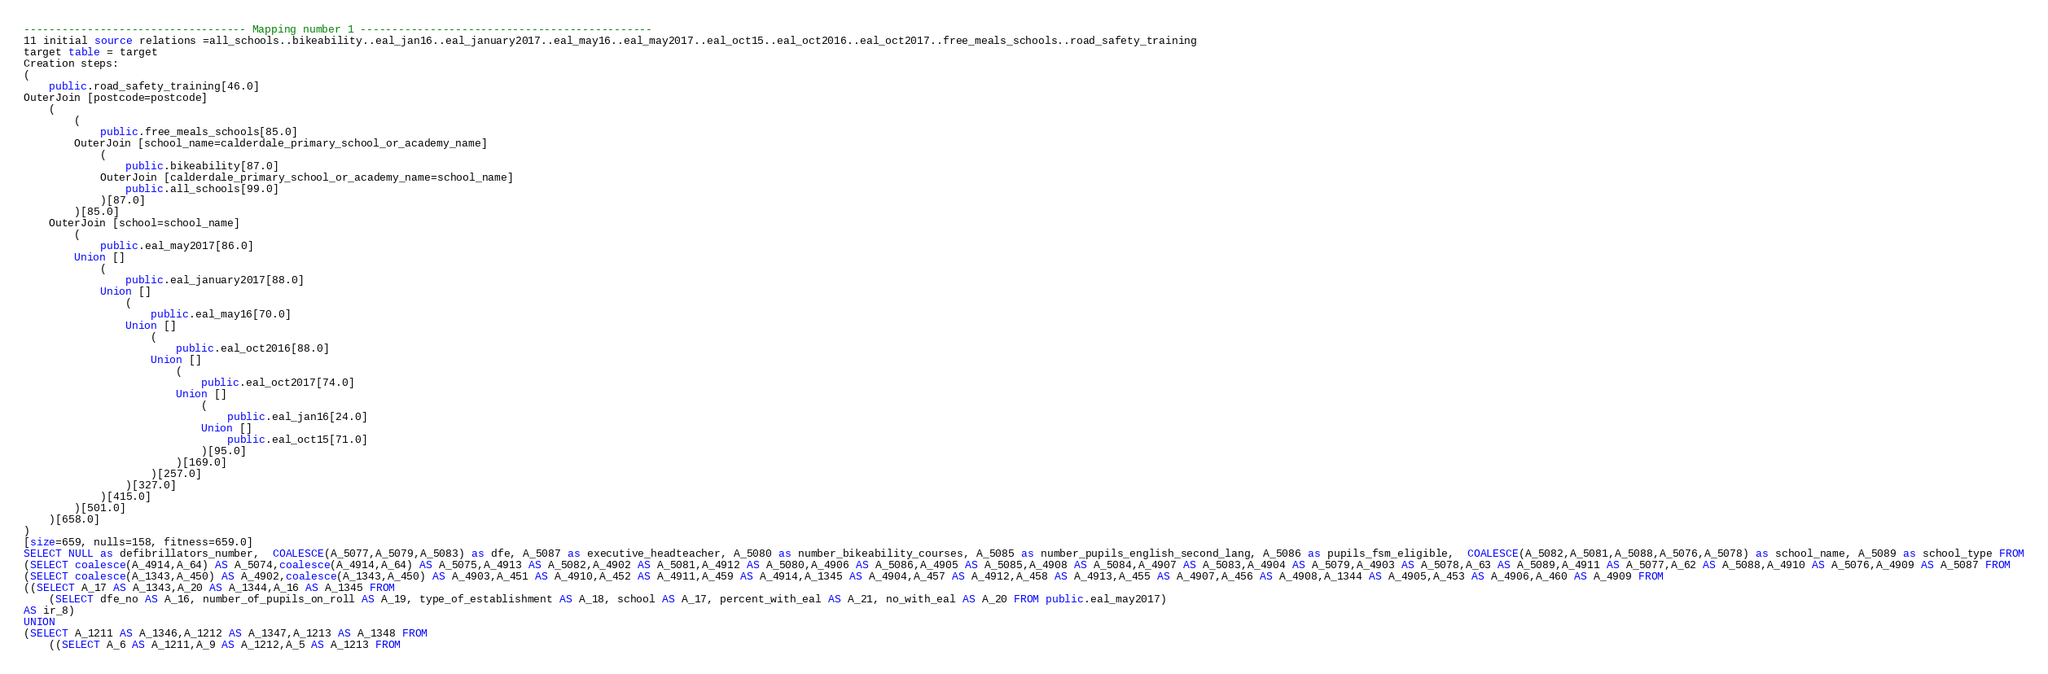Convert code to text. <code><loc_0><loc_0><loc_500><loc_500><_SQL_>
----------------------------------- Mapping number 1 ----------------------------------------------
11 initial source relations =all_schools..bikeability..eal_jan16..eal_january2017..eal_may16..eal_may2017..eal_oct15..eal_oct2016..eal_oct2017..free_meals_schools..road_safety_training
target table = target
Creation steps:
(
	public.road_safety_training[46.0]
OuterJoin [postcode=postcode]
	(
		(
			public.free_meals_schools[85.0]
		OuterJoin [school_name=calderdale_primary_school_or_academy_name]
			(
				public.bikeability[87.0]
			OuterJoin [calderdale_primary_school_or_academy_name=school_name]
				public.all_schools[99.0]
			)[87.0]
		)[85.0]
	OuterJoin [school=school_name]
		(
			public.eal_may2017[86.0]
		Union []
			(
				public.eal_january2017[88.0]
			Union []
				(
					public.eal_may16[70.0]
				Union []
					(
						public.eal_oct2016[88.0]
					Union []
						(
							public.eal_oct2017[74.0]
						Union []
							(
								public.eal_jan16[24.0]
							Union []
								public.eal_oct15[71.0]
							)[95.0]
						)[169.0]
					)[257.0]
				)[327.0]
			)[415.0]
		)[501.0]
	)[658.0]
)
[size=659, nulls=158, fitness=659.0]
SELECT NULL as defibrillators_number,  COALESCE(A_5077,A_5079,A_5083) as dfe, A_5087 as executive_headteacher, A_5080 as number_bikeability_courses, A_5085 as number_pupils_english_second_lang, A_5086 as pupils_fsm_eligible,  COALESCE(A_5082,A_5081,A_5088,A_5076,A_5078) as school_name, A_5089 as school_type FROM
(SELECT coalesce(A_4914,A_64) AS A_5074,coalesce(A_4914,A_64) AS A_5075,A_4913 AS A_5082,A_4902 AS A_5081,A_4912 AS A_5080,A_4906 AS A_5086,A_4905 AS A_5085,A_4908 AS A_5084,A_4907 AS A_5083,A_4904 AS A_5079,A_4903 AS A_5078,A_63 AS A_5089,A_4911 AS A_5077,A_62 AS A_5088,A_4910 AS A_5076,A_4909 AS A_5087 FROM 
(SELECT coalesce(A_1343,A_450) AS A_4902,coalesce(A_1343,A_450) AS A_4903,A_451 AS A_4910,A_452 AS A_4911,A_459 AS A_4914,A_1345 AS A_4904,A_457 AS A_4912,A_458 AS A_4913,A_455 AS A_4907,A_456 AS A_4908,A_1344 AS A_4905,A_453 AS A_4906,A_460 AS A_4909 FROM 
((SELECT A_17 AS A_1343,A_20 AS A_1344,A_16 AS A_1345 FROM 
	(SELECT dfe_no AS A_16, number_of_pupils_on_roll AS A_19, type_of_establishment AS A_18, school AS A_17, percent_with_eal AS A_21, no_with_eal AS A_20 FROM public.eal_may2017) 
AS ir_8) 
UNION 
(SELECT A_1211 AS A_1346,A_1212 AS A_1347,A_1213 AS A_1348 FROM 
	((SELECT A_6 AS A_1211,A_9 AS A_1212,A_5 AS A_1213 FROM </code> 